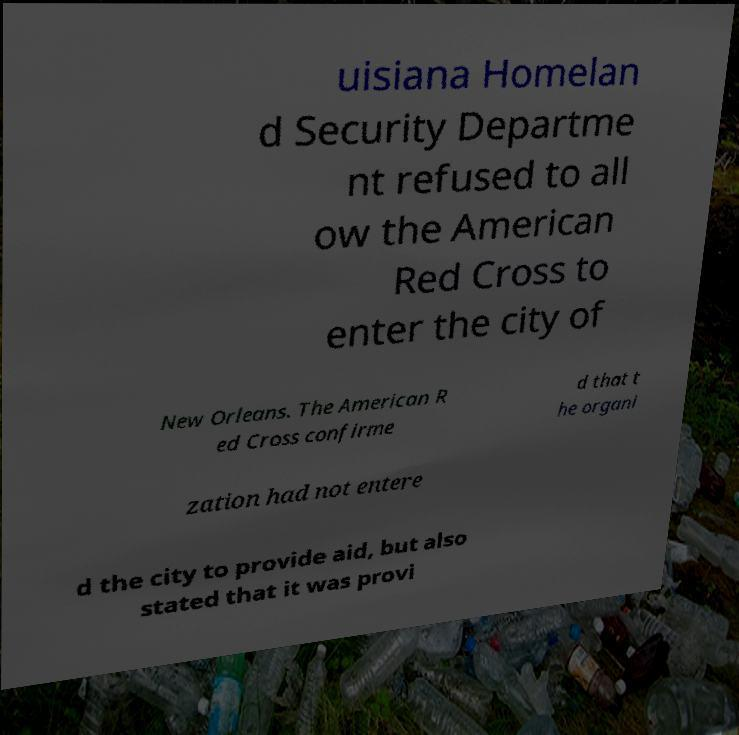Please read and relay the text visible in this image. What does it say? uisiana Homelan d Security Departme nt refused to all ow the American Red Cross to enter the city of New Orleans. The American R ed Cross confirme d that t he organi zation had not entere d the city to provide aid, but also stated that it was provi 